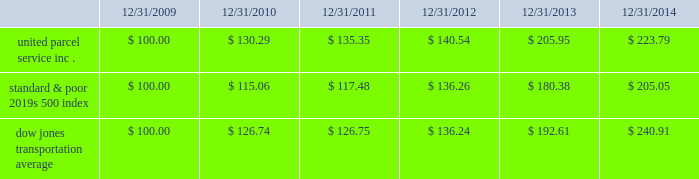Shareowner return performance graph the following performance graph and related information shall not be deemed 201csoliciting material 201d or to be 201cfiled 201d with the sec , nor shall such information be incorporated by reference into any future filing under the securities act of 1933 or securities exchange act of 1934 , each as amended , except to the extent that the company specifically incorporates such information by reference into such filing .
The following graph shows a five year comparison of cumulative total shareowners 2019 returns for our class b common stock , the standard & poor 2019s 500 index , and the dow jones transportation average .
The comparison of the total cumulative return on investment , which is the change in the quarterly stock price plus reinvested dividends for each of the quarterly periods , assumes that $ 100 was invested on december 31 , 2009 in the standard & poor 2019s 500 index , the dow jones transportation average , and our class b common stock. .

What was the percentage cumulative total shareowners 2019 returns for united parcel service inc . for the five years ended 12/31/2014? 
Computations: ((223.79 - 100) / 100)
Answer: 1.2379. 